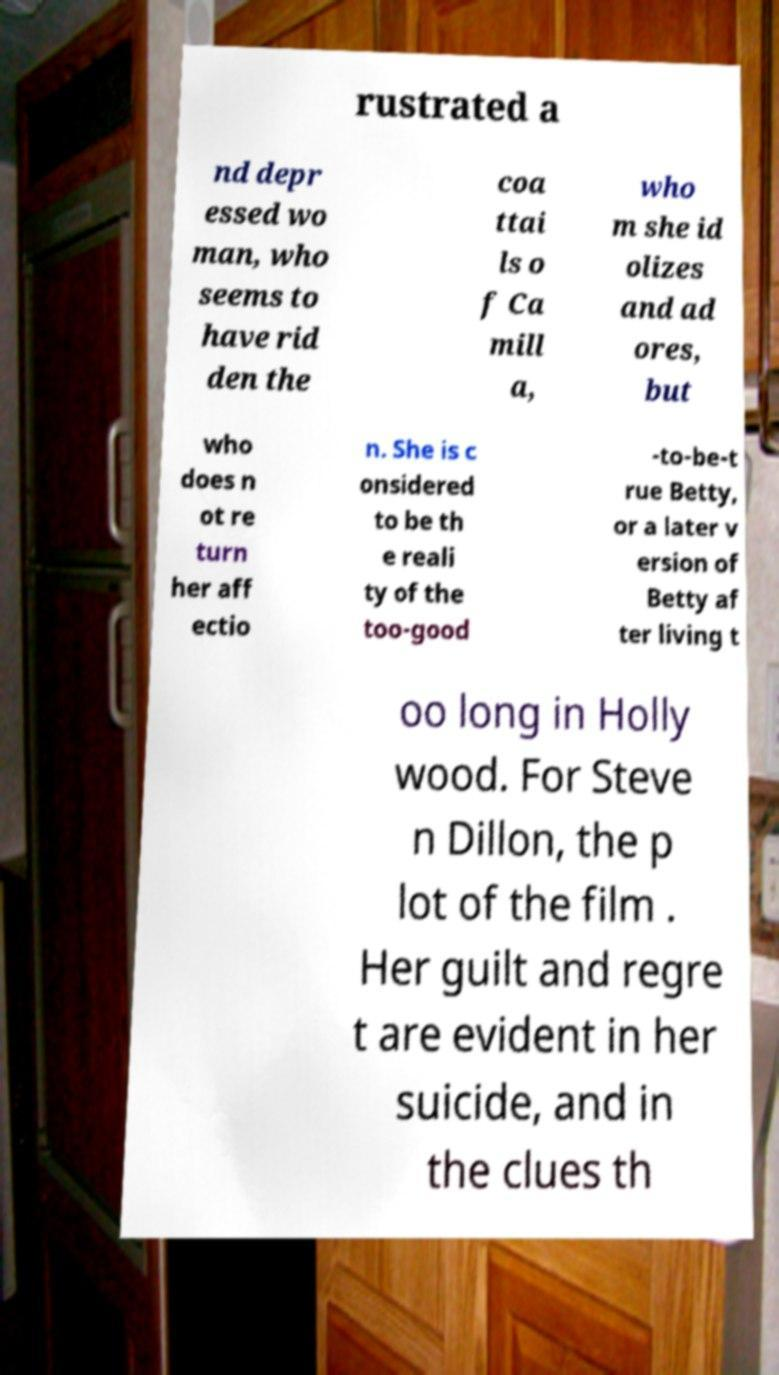Could you extract and type out the text from this image? rustrated a nd depr essed wo man, who seems to have rid den the coa ttai ls o f Ca mill a, who m she id olizes and ad ores, but who does n ot re turn her aff ectio n. She is c onsidered to be th e reali ty of the too-good -to-be-t rue Betty, or a later v ersion of Betty af ter living t oo long in Holly wood. For Steve n Dillon, the p lot of the film . Her guilt and regre t are evident in her suicide, and in the clues th 